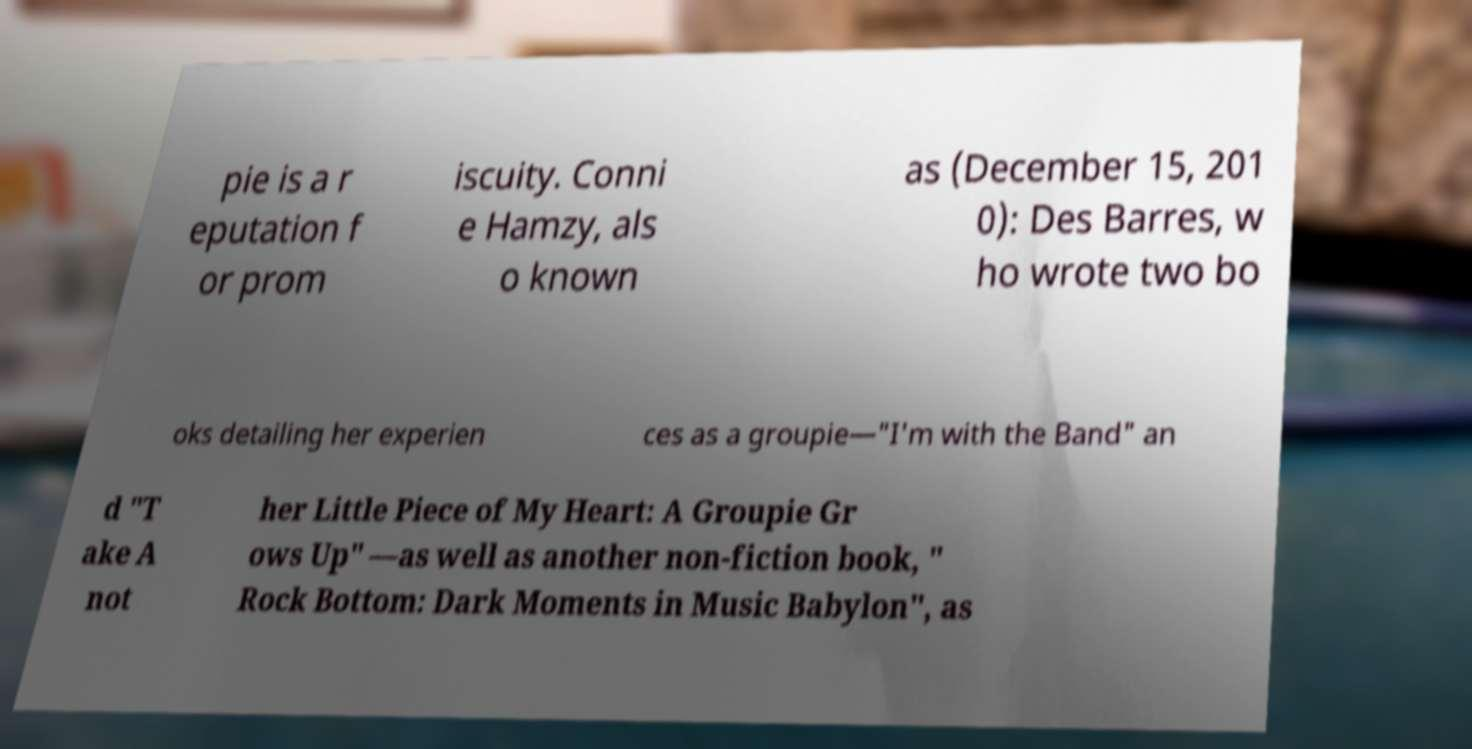Can you accurately transcribe the text from the provided image for me? pie is a r eputation f or prom iscuity. Conni e Hamzy, als o known as (December 15, 201 0): Des Barres, w ho wrote two bo oks detailing her experien ces as a groupie—"I'm with the Band" an d "T ake A not her Little Piece of My Heart: A Groupie Gr ows Up" —as well as another non-fiction book, " Rock Bottom: Dark Moments in Music Babylon", as 